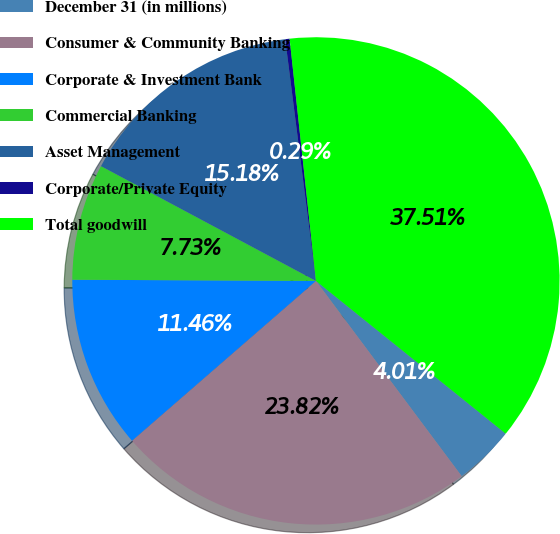<chart> <loc_0><loc_0><loc_500><loc_500><pie_chart><fcel>December 31 (in millions)<fcel>Consumer & Community Banking<fcel>Corporate & Investment Bank<fcel>Commercial Banking<fcel>Asset Management<fcel>Corporate/Private Equity<fcel>Total goodwill<nl><fcel>4.01%<fcel>23.82%<fcel>11.46%<fcel>7.73%<fcel>15.18%<fcel>0.29%<fcel>37.51%<nl></chart> 